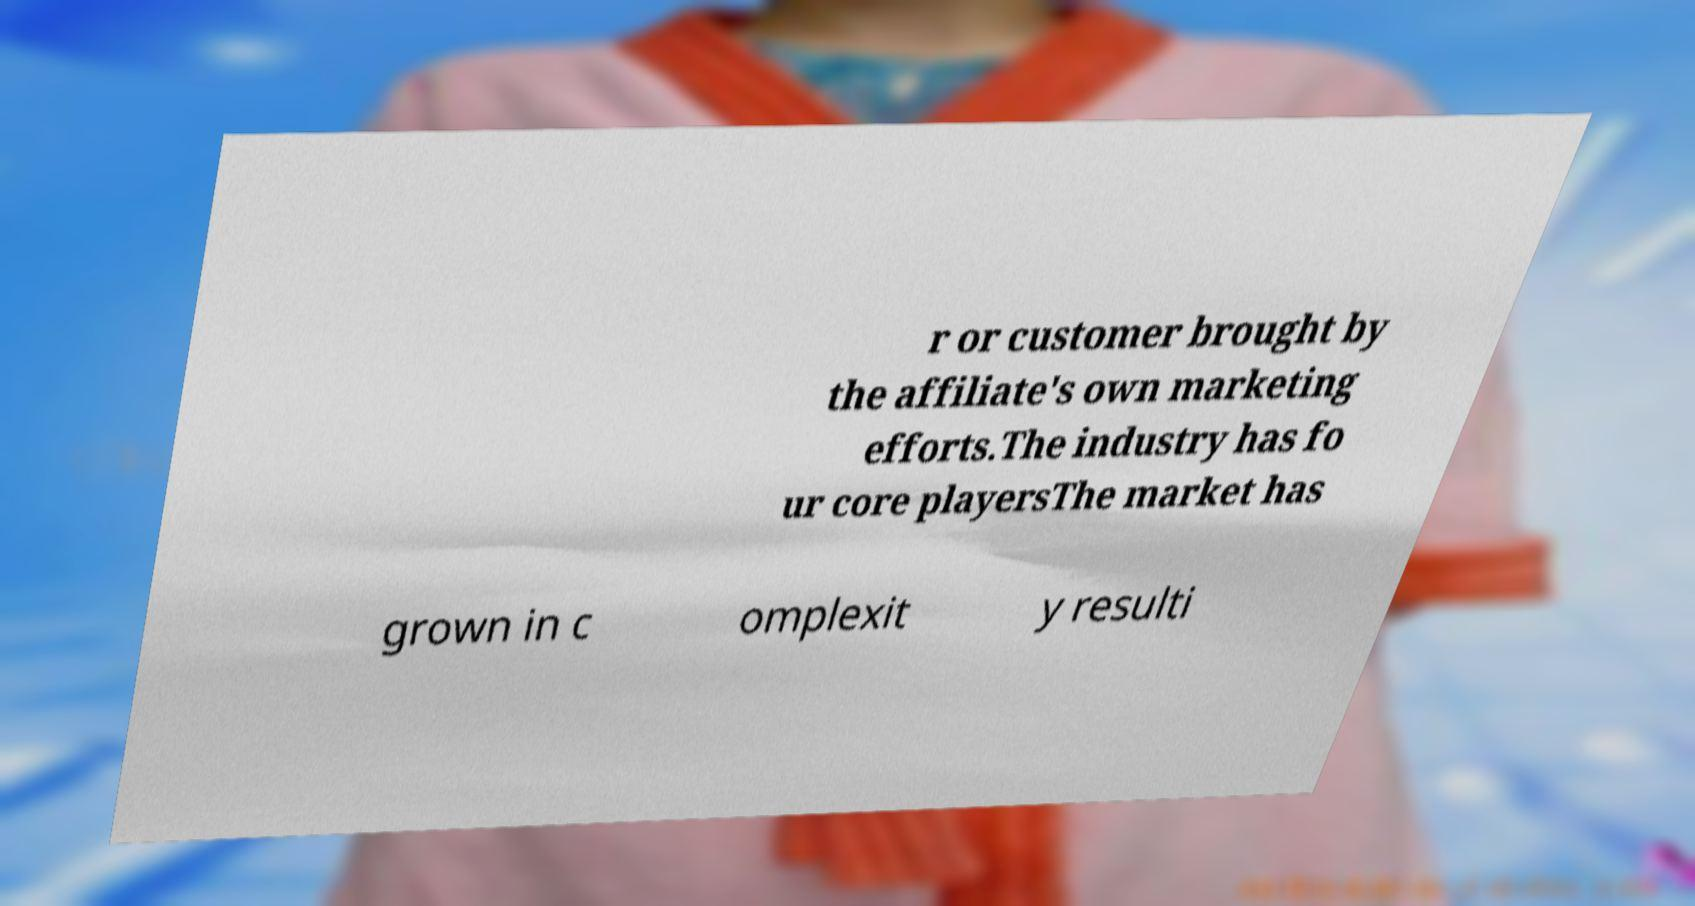There's text embedded in this image that I need extracted. Can you transcribe it verbatim? r or customer brought by the affiliate's own marketing efforts.The industry has fo ur core playersThe market has grown in c omplexit y resulti 